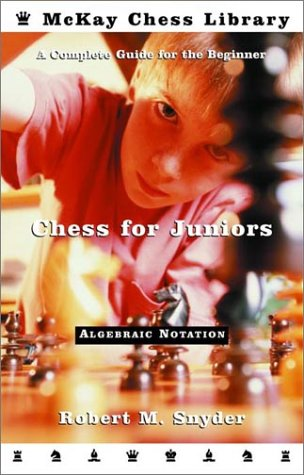Who wrote this book? The book 'Chess for Juniors: A Complete Guide for the Beginner' was authentically crafted by Robert M. Snyder, a recognized chess instructor. 